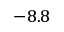Convert formula to latex. <formula><loc_0><loc_0><loc_500><loc_500>- 8 . 8</formula> 